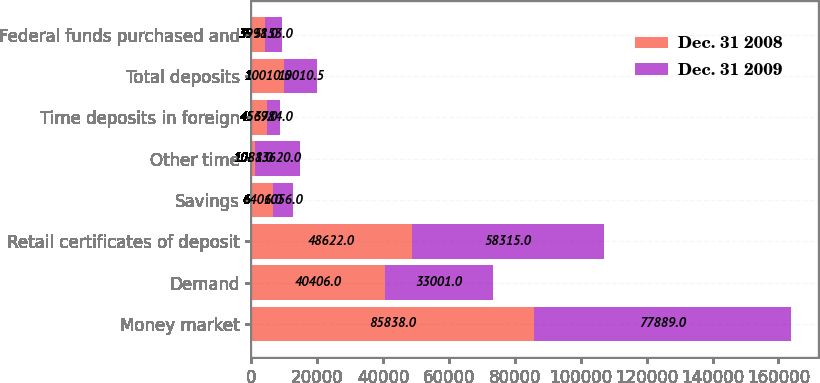<chart> <loc_0><loc_0><loc_500><loc_500><stacked_bar_chart><ecel><fcel>Money market<fcel>Demand<fcel>Retail certificates of deposit<fcel>Savings<fcel>Other time<fcel>Time deposits in foreign<fcel>Total deposits<fcel>Federal funds purchased and<nl><fcel>Dec. 31 2008<fcel>85838<fcel>40406<fcel>48622<fcel>6401<fcel>1088<fcel>4567<fcel>10010.5<fcel>3998<nl><fcel>Dec. 31 2009<fcel>77889<fcel>33001<fcel>58315<fcel>6056<fcel>13620<fcel>3984<fcel>10010.5<fcel>5153<nl></chart> 